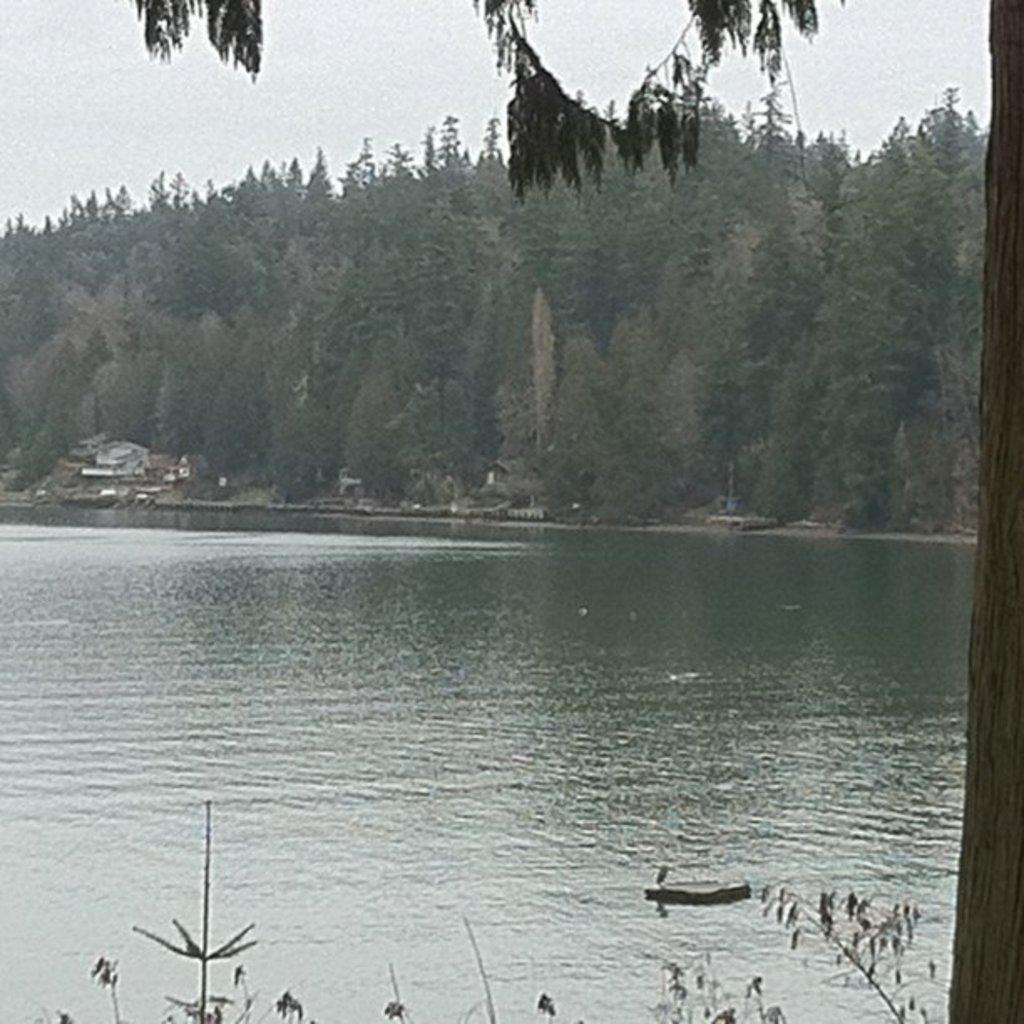What type of natural body of water is present in the image? There is a lake in the image. What other types of vegetation can be seen in the image besides the lake? There are plants and trees visible in the image. What type of man-made structures are present in the image? There are buildings present in the image. What is visible at the top of the image? The sky is visible in the image. What type of rock is being used to sew a needle and thread in the image? There is no rock, needle, or thread present in the image. What type of bag is being used to carry the plants in the image? There is no bag present in the image, and the plants are not being carried. 